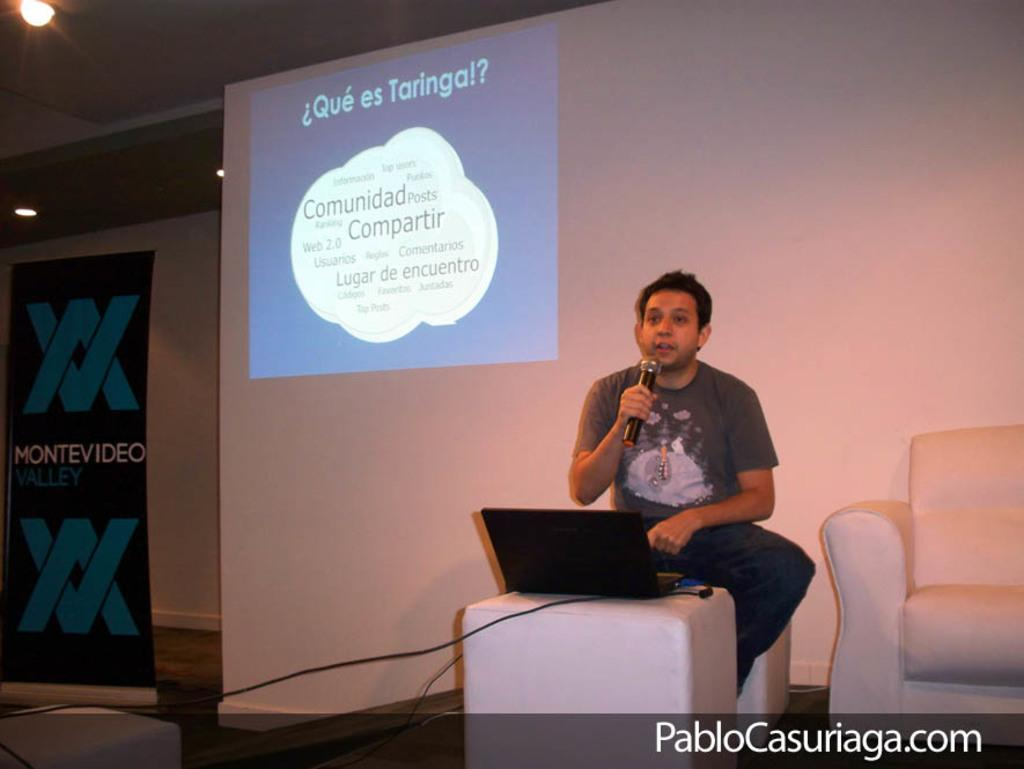What is the person in the image doing? The person is sitting on a chair and talking. What object is the person holding? The person is holding a microphone. What is on the table in the image? There is a laptop and a wire on the table. What can be seen in the background of the image? In the background, there is a screen, a poster, lights, and a sofa. What is the weight of the silk wrench in the image? There is no silk wrench present in the image. 